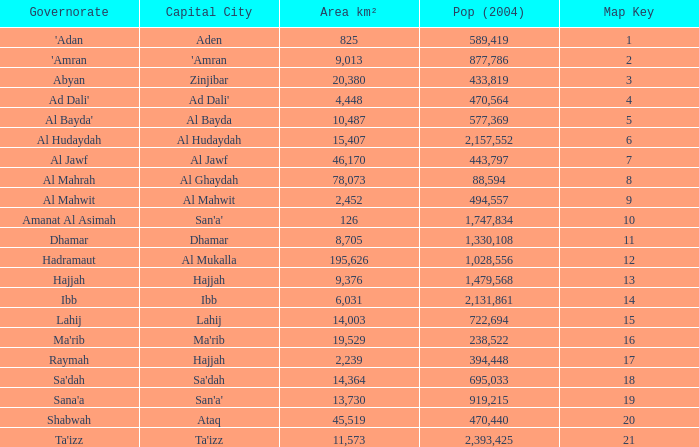How many Pop (2004) has a Governorate of al mahwit? 494557.0. 